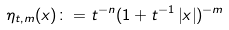<formula> <loc_0><loc_0><loc_500><loc_500>\eta _ { t , m } ( x ) \colon = t ^ { - n } ( 1 + t ^ { - 1 } \left | x \right | ) ^ { - m }</formula> 